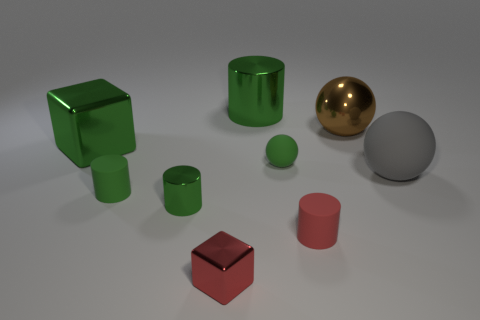How many green cylinders must be subtracted to get 1 green cylinders? 2 Subtract all purple blocks. How many green cylinders are left? 3 Add 1 big brown spheres. How many objects exist? 10 Subtract all cylinders. How many objects are left? 5 Add 7 big gray matte spheres. How many big gray matte spheres exist? 8 Subtract 0 purple blocks. How many objects are left? 9 Subtract all big brown shiny objects. Subtract all tiny red cubes. How many objects are left? 7 Add 8 tiny red objects. How many tiny red objects are left? 10 